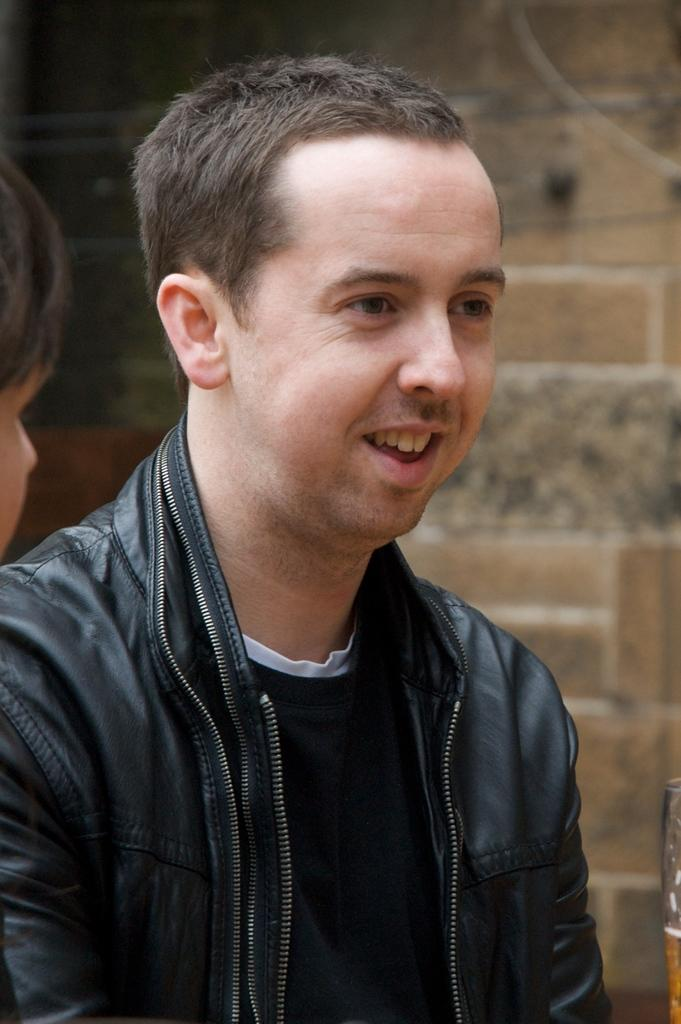What is the person in the image wearing? The person in the image is wearing a black jacket. Can you describe the other person in the image? There is another person on the left side of the image. What is located at the back of the image? There is a wall at the back of the image. What type of ink is being used by the person in the image? There is no indication in the image that the person is using ink, as they are wearing a black jacket and there are no visible writing instruments. 